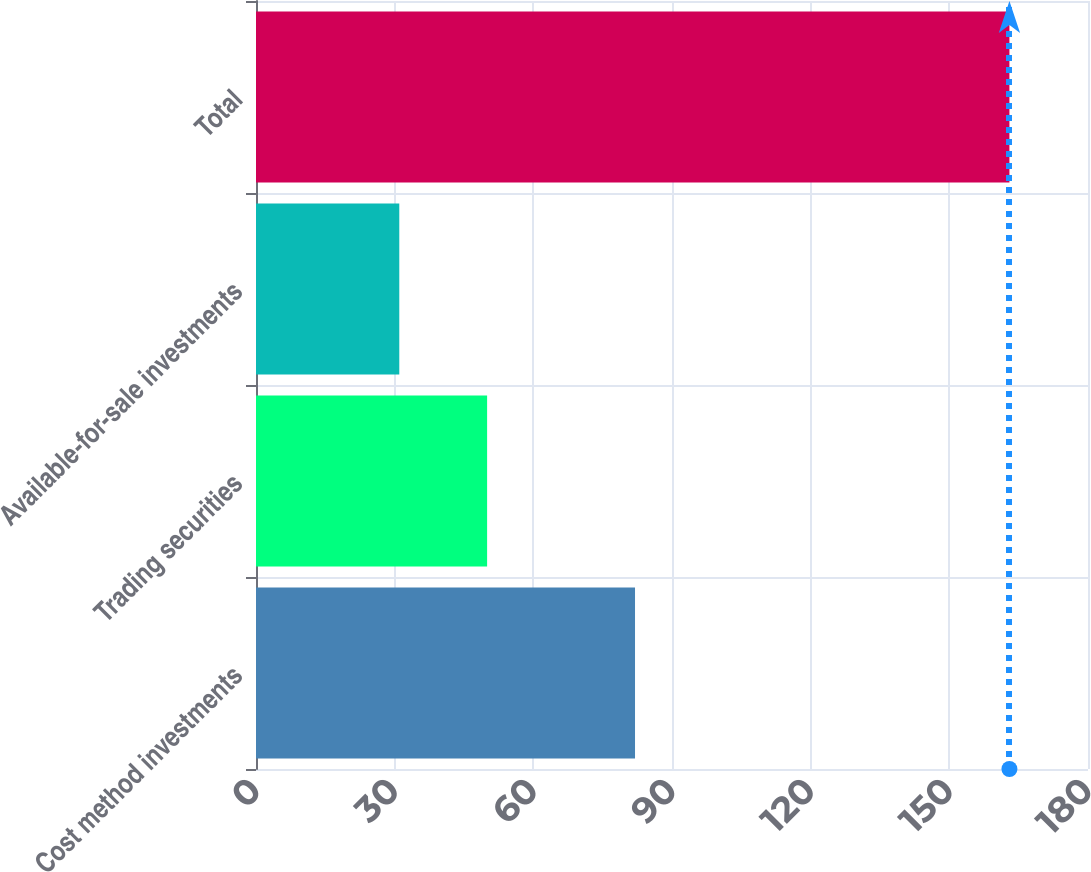<chart> <loc_0><loc_0><loc_500><loc_500><bar_chart><fcel>Cost method investments<fcel>Trading securities<fcel>Available-for-sale investments<fcel>Total<nl><fcel>82<fcel>50<fcel>31<fcel>163<nl></chart> 